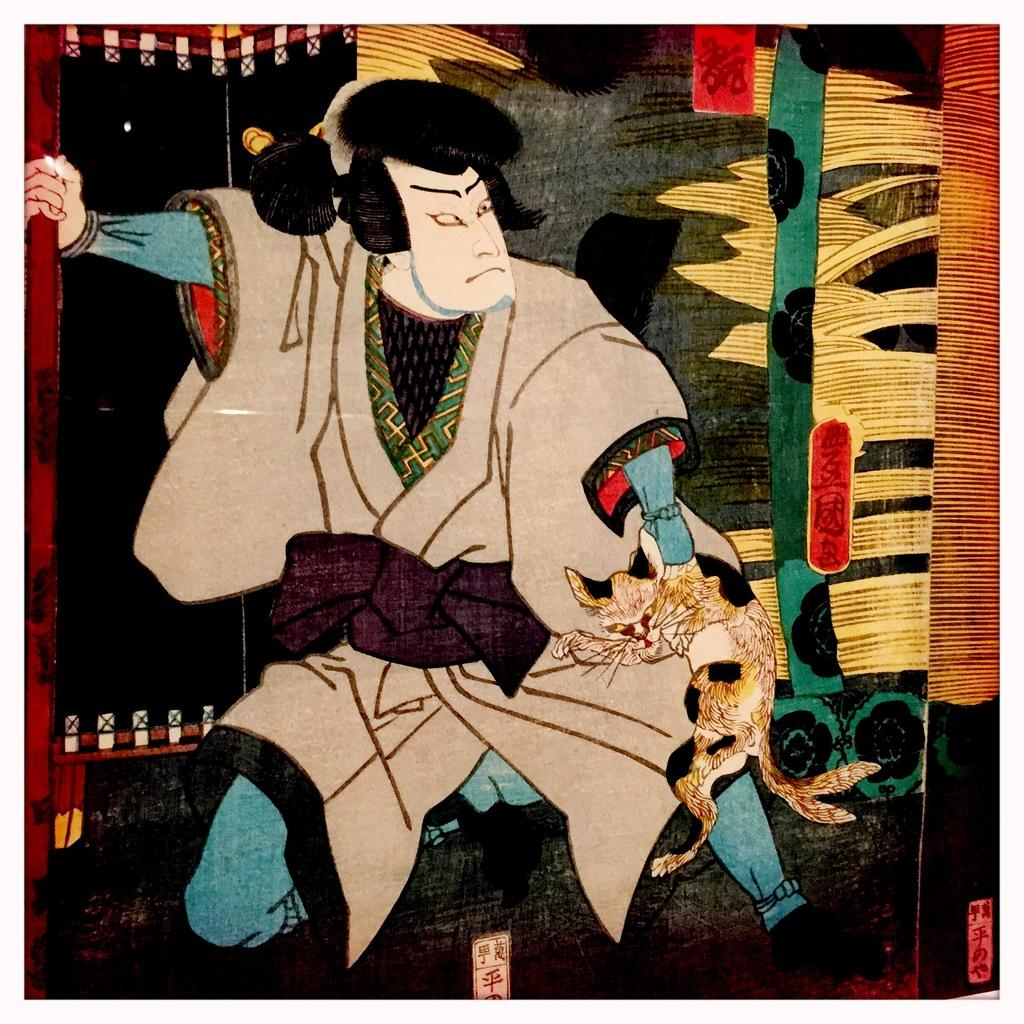What is the main subject of the image? There is a painting in the image. What is depicted in the painting? The painting depicts a person. What is the person holding in the painting? The person is holding a cat in the painting. Where is the throne located in the image? There is no throne present in the image. Can you describe the person's ability to jump in the painting? The painting does not depict the person jumping, so it is not possible to describe their ability to jump. 